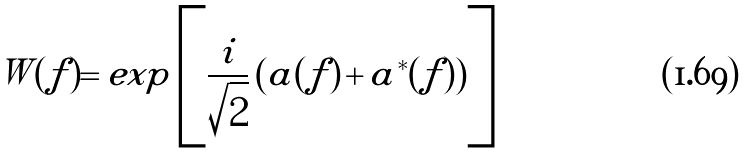<formula> <loc_0><loc_0><loc_500><loc_500>W ( f ) = e x p \left [ \frac { i } { \sqrt { 2 } } \left ( a ( f ) \, + \, a ^ { * } ( f ) \right ) \right ] \,</formula> 